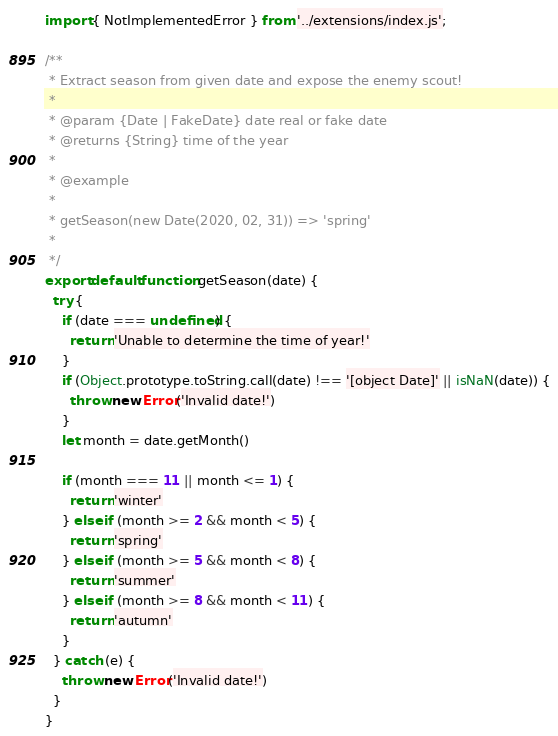<code> <loc_0><loc_0><loc_500><loc_500><_JavaScript_>import { NotImplementedError } from '../extensions/index.js';

/**
 * Extract season from given date and expose the enemy scout!
 * 
 * @param {Date | FakeDate} date real or fake date
 * @returns {String} time of the year
 * 
 * @example
 * 
 * getSeason(new Date(2020, 02, 31)) => 'spring'
 * 
 */
export default function getSeason(date) {
  try {
    if (date === undefined) {
      return 'Unable to determine the time of year!'
    }
    if (Object.prototype.toString.call(date) !== '[object Date]' || isNaN(date)) {
      throw new Error('Invalid date!')
    }
    let month = date.getMonth()

    if (month === 11 || month <= 1) {
      return 'winter'
    } else if (month >= 2 && month < 5) {
      return 'spring'
    } else if (month >= 5 && month < 8) {
      return 'summer'
    } else if (month >= 8 && month < 11) {
      return 'autumn'
    }
  } catch (e) {
    throw new Error('Invalid date!')
  }
}
</code> 